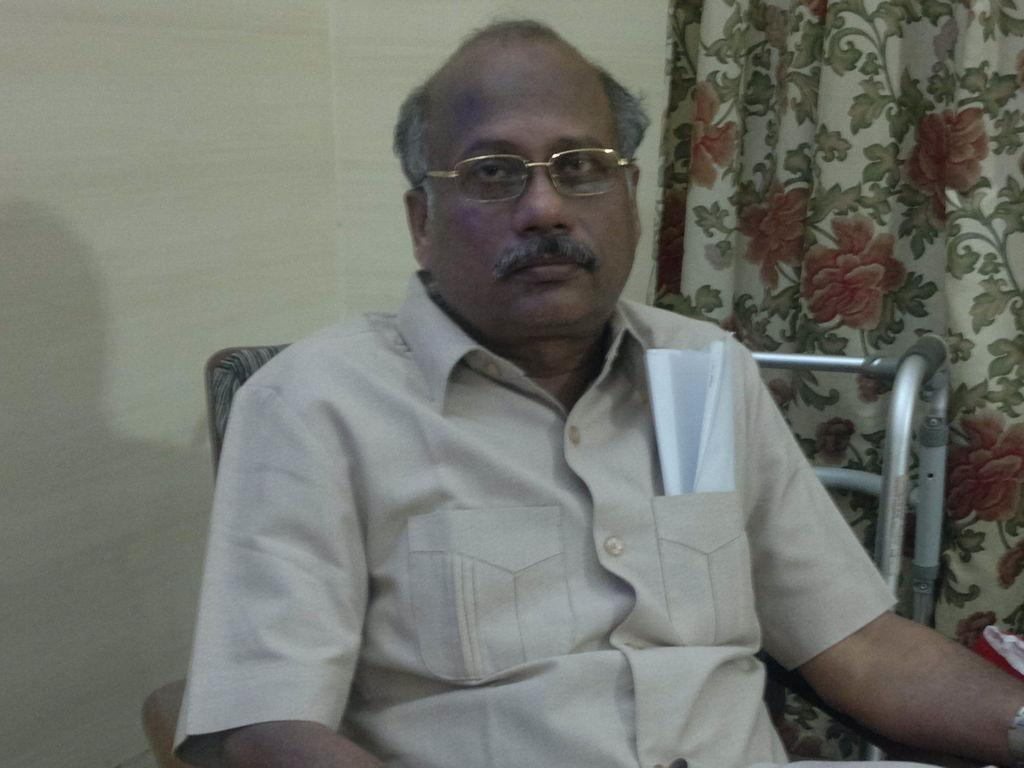Who is present in the image? There is a man in the image. What is the man wearing? The man is wearing glasses. What is the man's position in the image? The man is sitting on a chair. What can be seen behind the man in the image? There is a wall and a curtain in the image. What other objects can be seen in the image? There are other objects visible in the image. What type of cherry is the man holding in the image? There is no cherry present in the image; the man is not holding anything. What is the man's opinion on the kettle in the image? There is no kettle present in the image, so it is not possible to determine the man's opinion on it. 